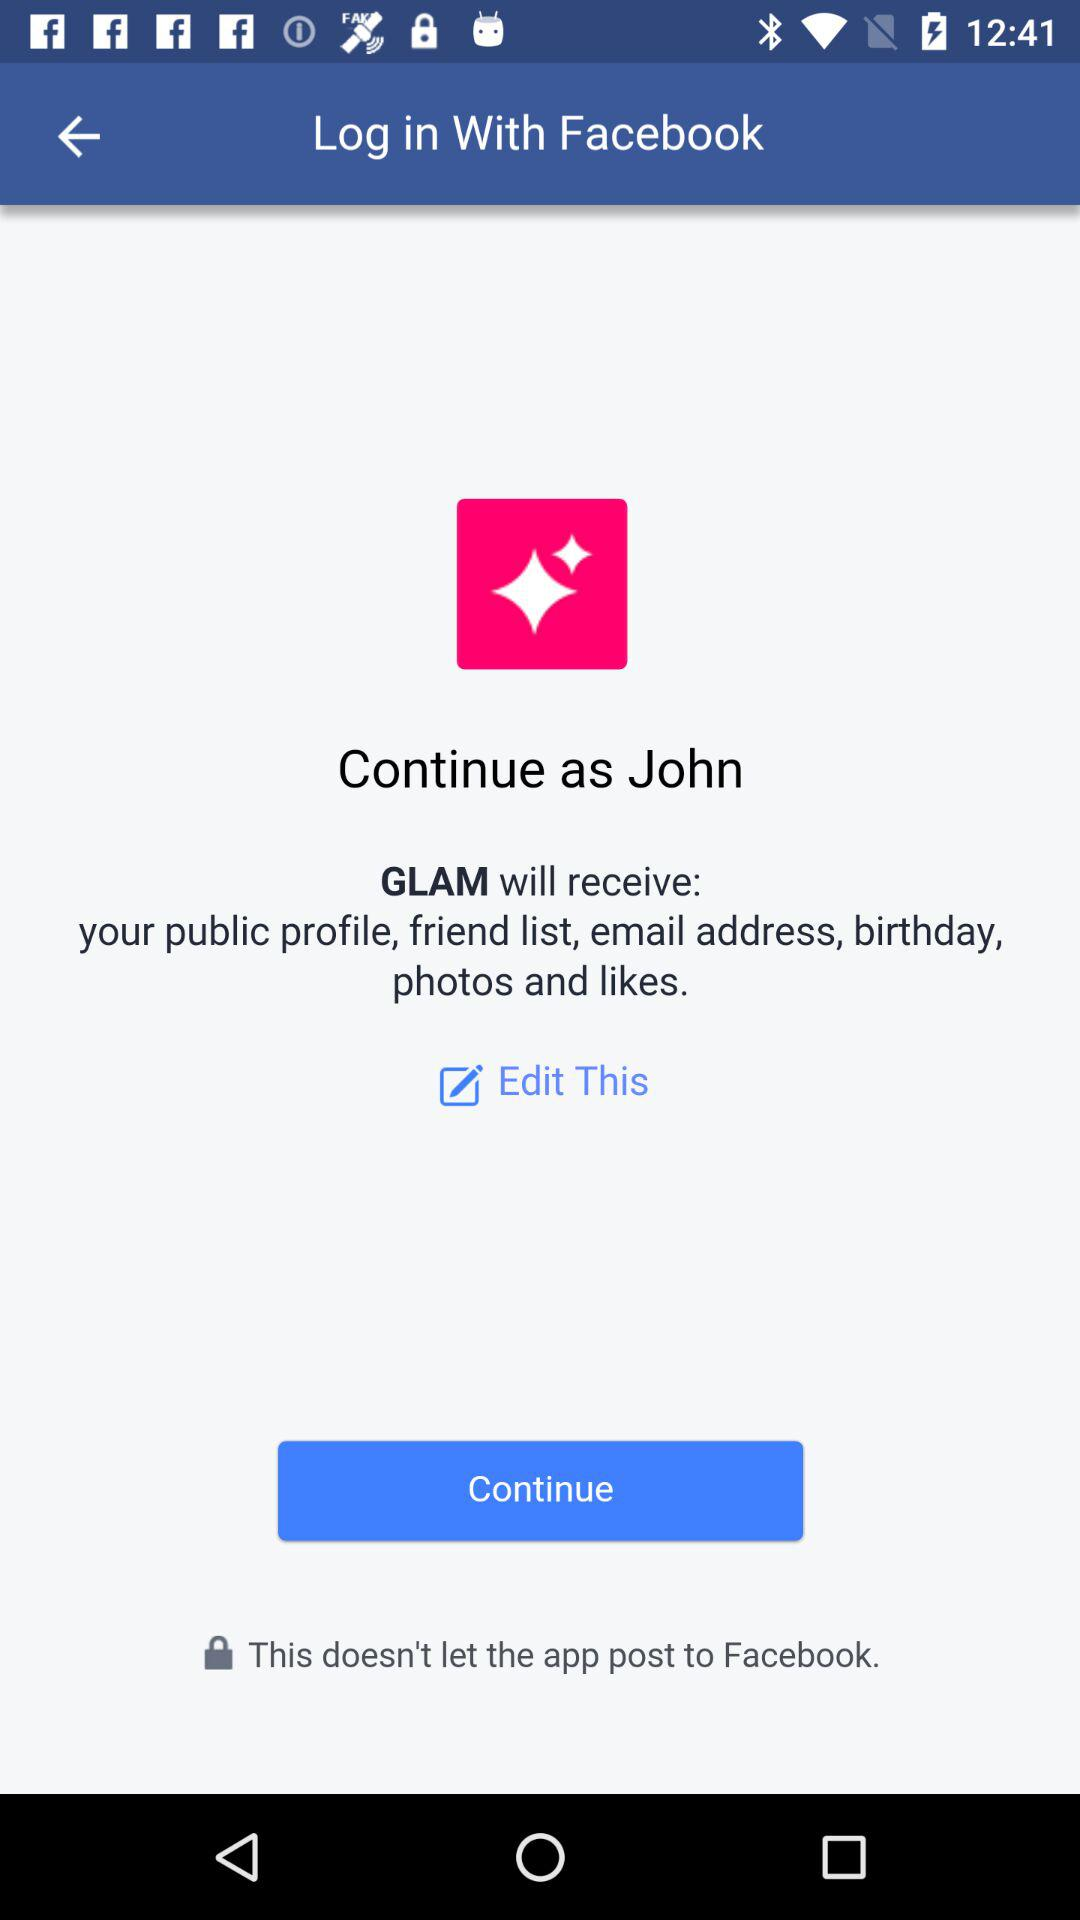What application will receive a public profile and email address? The application is "GLAM". 